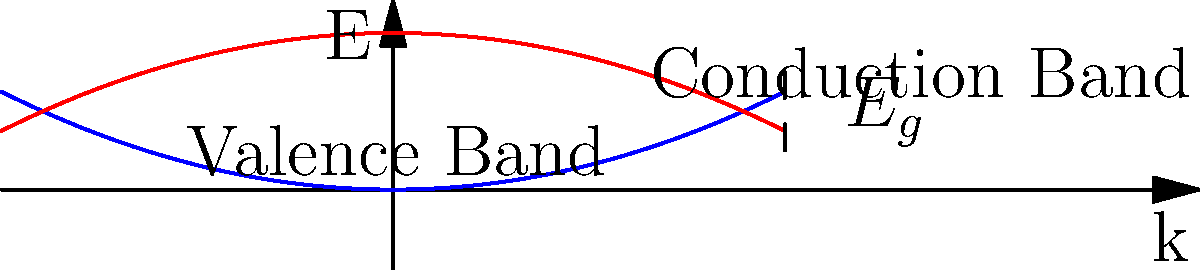Consider the E-k diagram of a nanoscale semiconductor device shown above. If an electron in the conduction band at $k = 0$ transitions to the valence band, what is the expression for the energy of the emitted photon in terms of the bandgap energy $E_g$ and the effective masses of the electron ($m_e^*$) and hole ($m_h^*$)? To solve this problem, we need to follow these steps:

1) In the E-k diagram, the conduction and valence bands are represented by parabolic curves. At $k = 0$, the energy difference between these bands is equal to the bandgap energy $E_g$.

2) The energy of an electron in the conduction band at $k = 0$ is $E_c = E_g$.

3) The energy of a hole in the valence band at $k = 0$ is $E_v = 0$.

4) When an electron transitions from the conduction band to the valence band, it emits a photon. The energy of this photon is equal to the energy difference between the initial and final states of the electron.

5) However, we need to consider the curvature of the bands, which is related to the effective masses of the electron and hole. The energy-momentum relation near $k = 0$ for the conduction and valence bands can be approximated as:

   $E_c(k) = E_g + \frac{\hbar^2k^2}{2m_e^*}$
   $E_v(k) = -\frac{\hbar^2k^2}{2m_h^*}$

6) The energy of the emitted photon is:

   $E_{photon} = E_c(k) - E_v(k) = E_g + \frac{\hbar^2k^2}{2m_e^*} + \frac{\hbar^2k^2}{2m_h^*}$

7) This can be rewritten as:

   $E_{photon} = E_g + \frac{\hbar^2k^2}{2}\left(\frac{1}{m_e^*} + \frac{1}{m_h^*}\right)$

8) Define the reduced mass $\mu$ as:

   $\frac{1}{\mu} = \frac{1}{m_e^*} + \frac{1}{m_h^*}$

9) The final expression for the energy of the emitted photon is:

   $E_{photon} = E_g + \frac{\hbar^2k^2}{2\mu}$

This expression accounts for the bandgap energy and the curvature of both the conduction and valence bands.
Answer: $E_{photon} = E_g + \frac{\hbar^2k^2}{2\mu}$, where $\frac{1}{\mu} = \frac{1}{m_e^*} + \frac{1}{m_h^*}$ 